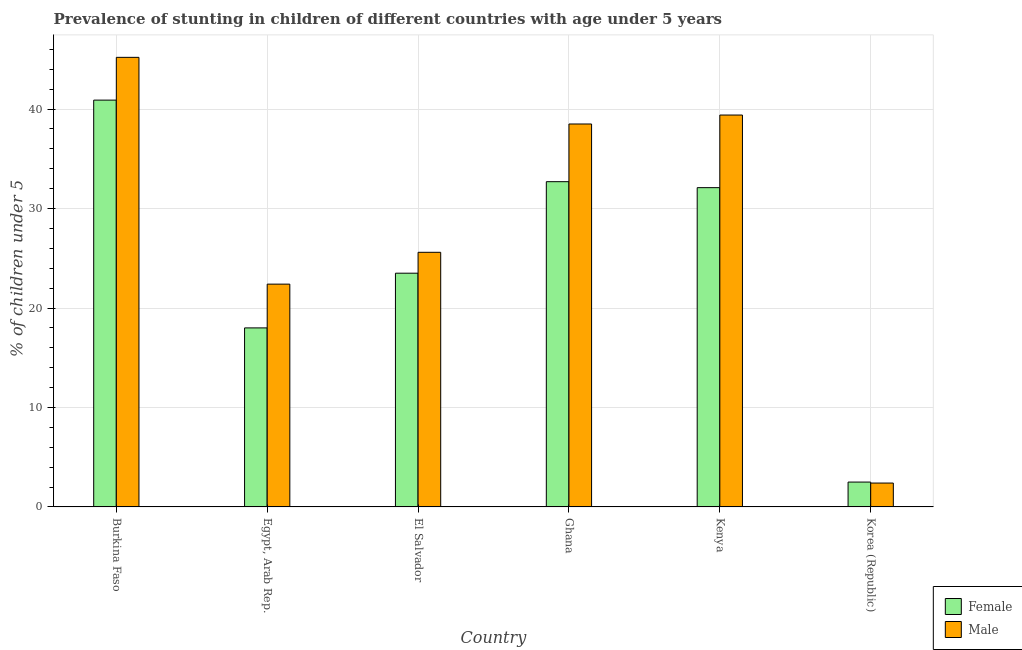How many different coloured bars are there?
Offer a very short reply. 2. Are the number of bars per tick equal to the number of legend labels?
Keep it short and to the point. Yes. Are the number of bars on each tick of the X-axis equal?
Give a very brief answer. Yes. How many bars are there on the 4th tick from the left?
Ensure brevity in your answer.  2. What is the label of the 1st group of bars from the left?
Your answer should be compact. Burkina Faso. In how many cases, is the number of bars for a given country not equal to the number of legend labels?
Provide a short and direct response. 0. What is the percentage of stunted female children in Kenya?
Provide a short and direct response. 32.1. Across all countries, what is the maximum percentage of stunted male children?
Your answer should be very brief. 45.2. Across all countries, what is the minimum percentage of stunted female children?
Ensure brevity in your answer.  2.5. In which country was the percentage of stunted female children maximum?
Your answer should be compact. Burkina Faso. In which country was the percentage of stunted female children minimum?
Your answer should be compact. Korea (Republic). What is the total percentage of stunted male children in the graph?
Offer a very short reply. 173.5. What is the difference between the percentage of stunted male children in Kenya and that in Korea (Republic)?
Make the answer very short. 37. What is the difference between the percentage of stunted male children in Ghana and the percentage of stunted female children in Egypt, Arab Rep.?
Give a very brief answer. 20.5. What is the average percentage of stunted female children per country?
Give a very brief answer. 24.95. What is the difference between the percentage of stunted male children and percentage of stunted female children in El Salvador?
Provide a succinct answer. 2.1. In how many countries, is the percentage of stunted female children greater than 8 %?
Provide a succinct answer. 5. What is the ratio of the percentage of stunted female children in Burkina Faso to that in Korea (Republic)?
Make the answer very short. 16.36. Is the percentage of stunted male children in Egypt, Arab Rep. less than that in El Salvador?
Offer a very short reply. Yes. What is the difference between the highest and the second highest percentage of stunted male children?
Provide a succinct answer. 5.8. What is the difference between the highest and the lowest percentage of stunted male children?
Keep it short and to the point. 42.8. In how many countries, is the percentage of stunted male children greater than the average percentage of stunted male children taken over all countries?
Your answer should be compact. 3. What does the 2nd bar from the left in Kenya represents?
Provide a succinct answer. Male. What does the 1st bar from the right in El Salvador represents?
Make the answer very short. Male. Are all the bars in the graph horizontal?
Provide a short and direct response. No. Are the values on the major ticks of Y-axis written in scientific E-notation?
Provide a short and direct response. No. Does the graph contain any zero values?
Ensure brevity in your answer.  No. Does the graph contain grids?
Offer a very short reply. Yes. How are the legend labels stacked?
Provide a short and direct response. Vertical. What is the title of the graph?
Offer a very short reply. Prevalence of stunting in children of different countries with age under 5 years. Does "IMF nonconcessional" appear as one of the legend labels in the graph?
Your response must be concise. No. What is the label or title of the Y-axis?
Provide a succinct answer.  % of children under 5. What is the  % of children under 5 of Female in Burkina Faso?
Provide a short and direct response. 40.9. What is the  % of children under 5 in Male in Burkina Faso?
Provide a succinct answer. 45.2. What is the  % of children under 5 in Male in Egypt, Arab Rep.?
Give a very brief answer. 22.4. What is the  % of children under 5 of Male in El Salvador?
Make the answer very short. 25.6. What is the  % of children under 5 of Female in Ghana?
Give a very brief answer. 32.7. What is the  % of children under 5 in Male in Ghana?
Provide a short and direct response. 38.5. What is the  % of children under 5 of Female in Kenya?
Provide a short and direct response. 32.1. What is the  % of children under 5 in Male in Kenya?
Make the answer very short. 39.4. What is the  % of children under 5 of Male in Korea (Republic)?
Provide a short and direct response. 2.4. Across all countries, what is the maximum  % of children under 5 of Female?
Your answer should be very brief. 40.9. Across all countries, what is the maximum  % of children under 5 of Male?
Your answer should be very brief. 45.2. Across all countries, what is the minimum  % of children under 5 of Female?
Your answer should be very brief. 2.5. Across all countries, what is the minimum  % of children under 5 of Male?
Offer a very short reply. 2.4. What is the total  % of children under 5 in Female in the graph?
Keep it short and to the point. 149.7. What is the total  % of children under 5 in Male in the graph?
Ensure brevity in your answer.  173.5. What is the difference between the  % of children under 5 of Female in Burkina Faso and that in Egypt, Arab Rep.?
Provide a short and direct response. 22.9. What is the difference between the  % of children under 5 in Male in Burkina Faso and that in Egypt, Arab Rep.?
Your response must be concise. 22.8. What is the difference between the  % of children under 5 of Male in Burkina Faso and that in El Salvador?
Your answer should be compact. 19.6. What is the difference between the  % of children under 5 in Female in Burkina Faso and that in Ghana?
Your answer should be very brief. 8.2. What is the difference between the  % of children under 5 in Male in Burkina Faso and that in Ghana?
Give a very brief answer. 6.7. What is the difference between the  % of children under 5 of Female in Burkina Faso and that in Kenya?
Your answer should be compact. 8.8. What is the difference between the  % of children under 5 in Female in Burkina Faso and that in Korea (Republic)?
Your answer should be compact. 38.4. What is the difference between the  % of children under 5 in Male in Burkina Faso and that in Korea (Republic)?
Provide a short and direct response. 42.8. What is the difference between the  % of children under 5 of Male in Egypt, Arab Rep. and that in El Salvador?
Your answer should be very brief. -3.2. What is the difference between the  % of children under 5 in Female in Egypt, Arab Rep. and that in Ghana?
Give a very brief answer. -14.7. What is the difference between the  % of children under 5 in Male in Egypt, Arab Rep. and that in Ghana?
Offer a very short reply. -16.1. What is the difference between the  % of children under 5 of Female in Egypt, Arab Rep. and that in Kenya?
Your response must be concise. -14.1. What is the difference between the  % of children under 5 in Male in Egypt, Arab Rep. and that in Kenya?
Give a very brief answer. -17. What is the difference between the  % of children under 5 in Male in El Salvador and that in Ghana?
Keep it short and to the point. -12.9. What is the difference between the  % of children under 5 of Female in El Salvador and that in Kenya?
Your answer should be compact. -8.6. What is the difference between the  % of children under 5 in Female in El Salvador and that in Korea (Republic)?
Offer a very short reply. 21. What is the difference between the  % of children under 5 in Male in El Salvador and that in Korea (Republic)?
Give a very brief answer. 23.2. What is the difference between the  % of children under 5 of Male in Ghana and that in Kenya?
Your response must be concise. -0.9. What is the difference between the  % of children under 5 of Female in Ghana and that in Korea (Republic)?
Provide a succinct answer. 30.2. What is the difference between the  % of children under 5 of Male in Ghana and that in Korea (Republic)?
Your answer should be compact. 36.1. What is the difference between the  % of children under 5 of Female in Kenya and that in Korea (Republic)?
Offer a very short reply. 29.6. What is the difference between the  % of children under 5 in Male in Kenya and that in Korea (Republic)?
Your response must be concise. 37. What is the difference between the  % of children under 5 in Female in Burkina Faso and the  % of children under 5 in Male in El Salvador?
Your answer should be compact. 15.3. What is the difference between the  % of children under 5 of Female in Burkina Faso and the  % of children under 5 of Male in Korea (Republic)?
Make the answer very short. 38.5. What is the difference between the  % of children under 5 of Female in Egypt, Arab Rep. and the  % of children under 5 of Male in Ghana?
Your answer should be very brief. -20.5. What is the difference between the  % of children under 5 in Female in Egypt, Arab Rep. and the  % of children under 5 in Male in Kenya?
Your answer should be very brief. -21.4. What is the difference between the  % of children under 5 of Female in Egypt, Arab Rep. and the  % of children under 5 of Male in Korea (Republic)?
Your answer should be compact. 15.6. What is the difference between the  % of children under 5 of Female in El Salvador and the  % of children under 5 of Male in Kenya?
Make the answer very short. -15.9. What is the difference between the  % of children under 5 of Female in El Salvador and the  % of children under 5 of Male in Korea (Republic)?
Ensure brevity in your answer.  21.1. What is the difference between the  % of children under 5 in Female in Ghana and the  % of children under 5 in Male in Korea (Republic)?
Your response must be concise. 30.3. What is the difference between the  % of children under 5 in Female in Kenya and the  % of children under 5 in Male in Korea (Republic)?
Your answer should be compact. 29.7. What is the average  % of children under 5 of Female per country?
Give a very brief answer. 24.95. What is the average  % of children under 5 of Male per country?
Give a very brief answer. 28.92. What is the difference between the  % of children under 5 in Female and  % of children under 5 in Male in Burkina Faso?
Make the answer very short. -4.3. What is the difference between the  % of children under 5 of Female and  % of children under 5 of Male in Korea (Republic)?
Give a very brief answer. 0.1. What is the ratio of the  % of children under 5 in Female in Burkina Faso to that in Egypt, Arab Rep.?
Your answer should be very brief. 2.27. What is the ratio of the  % of children under 5 in Male in Burkina Faso to that in Egypt, Arab Rep.?
Your answer should be compact. 2.02. What is the ratio of the  % of children under 5 in Female in Burkina Faso to that in El Salvador?
Make the answer very short. 1.74. What is the ratio of the  % of children under 5 of Male in Burkina Faso to that in El Salvador?
Give a very brief answer. 1.77. What is the ratio of the  % of children under 5 in Female in Burkina Faso to that in Ghana?
Offer a very short reply. 1.25. What is the ratio of the  % of children under 5 of Male in Burkina Faso to that in Ghana?
Provide a short and direct response. 1.17. What is the ratio of the  % of children under 5 in Female in Burkina Faso to that in Kenya?
Ensure brevity in your answer.  1.27. What is the ratio of the  % of children under 5 of Male in Burkina Faso to that in Kenya?
Give a very brief answer. 1.15. What is the ratio of the  % of children under 5 of Female in Burkina Faso to that in Korea (Republic)?
Offer a very short reply. 16.36. What is the ratio of the  % of children under 5 of Male in Burkina Faso to that in Korea (Republic)?
Provide a short and direct response. 18.83. What is the ratio of the  % of children under 5 of Female in Egypt, Arab Rep. to that in El Salvador?
Your answer should be very brief. 0.77. What is the ratio of the  % of children under 5 in Female in Egypt, Arab Rep. to that in Ghana?
Offer a terse response. 0.55. What is the ratio of the  % of children under 5 of Male in Egypt, Arab Rep. to that in Ghana?
Offer a terse response. 0.58. What is the ratio of the  % of children under 5 in Female in Egypt, Arab Rep. to that in Kenya?
Your answer should be compact. 0.56. What is the ratio of the  % of children under 5 in Male in Egypt, Arab Rep. to that in Kenya?
Keep it short and to the point. 0.57. What is the ratio of the  % of children under 5 in Female in Egypt, Arab Rep. to that in Korea (Republic)?
Offer a very short reply. 7.2. What is the ratio of the  % of children under 5 of Male in Egypt, Arab Rep. to that in Korea (Republic)?
Offer a terse response. 9.33. What is the ratio of the  % of children under 5 of Female in El Salvador to that in Ghana?
Provide a succinct answer. 0.72. What is the ratio of the  % of children under 5 in Male in El Salvador to that in Ghana?
Provide a succinct answer. 0.66. What is the ratio of the  % of children under 5 in Female in El Salvador to that in Kenya?
Keep it short and to the point. 0.73. What is the ratio of the  % of children under 5 of Male in El Salvador to that in Kenya?
Keep it short and to the point. 0.65. What is the ratio of the  % of children under 5 in Male in El Salvador to that in Korea (Republic)?
Offer a very short reply. 10.67. What is the ratio of the  % of children under 5 in Female in Ghana to that in Kenya?
Make the answer very short. 1.02. What is the ratio of the  % of children under 5 in Male in Ghana to that in Kenya?
Make the answer very short. 0.98. What is the ratio of the  % of children under 5 of Female in Ghana to that in Korea (Republic)?
Make the answer very short. 13.08. What is the ratio of the  % of children under 5 of Male in Ghana to that in Korea (Republic)?
Your answer should be compact. 16.04. What is the ratio of the  % of children under 5 of Female in Kenya to that in Korea (Republic)?
Your response must be concise. 12.84. What is the ratio of the  % of children under 5 of Male in Kenya to that in Korea (Republic)?
Offer a terse response. 16.42. What is the difference between the highest and the second highest  % of children under 5 in Male?
Provide a short and direct response. 5.8. What is the difference between the highest and the lowest  % of children under 5 of Female?
Your answer should be very brief. 38.4. What is the difference between the highest and the lowest  % of children under 5 in Male?
Offer a very short reply. 42.8. 